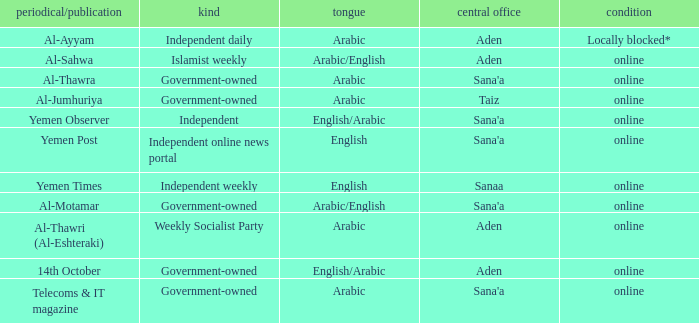What is Type, when Newspaper/Magazine is Telecoms & It Magazine? Government-owned. 